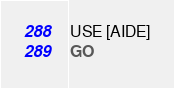<code> <loc_0><loc_0><loc_500><loc_500><_SQL_>USE [AIDE]
GO</code> 